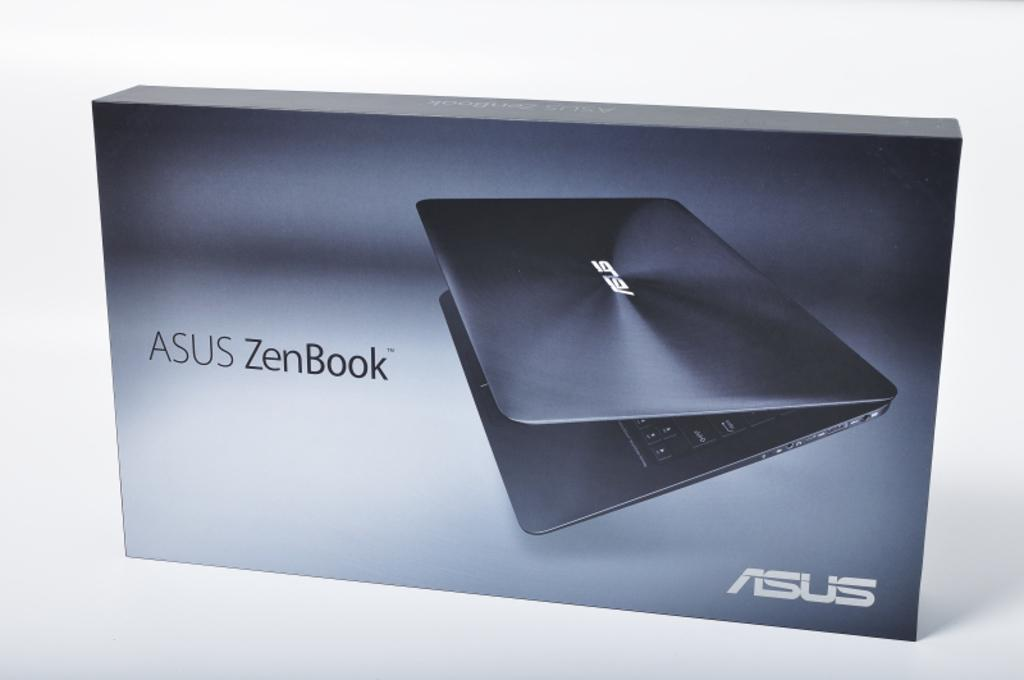Provide a one-sentence caption for the provided image. a computer box that says 'asus zenbook' on it. 